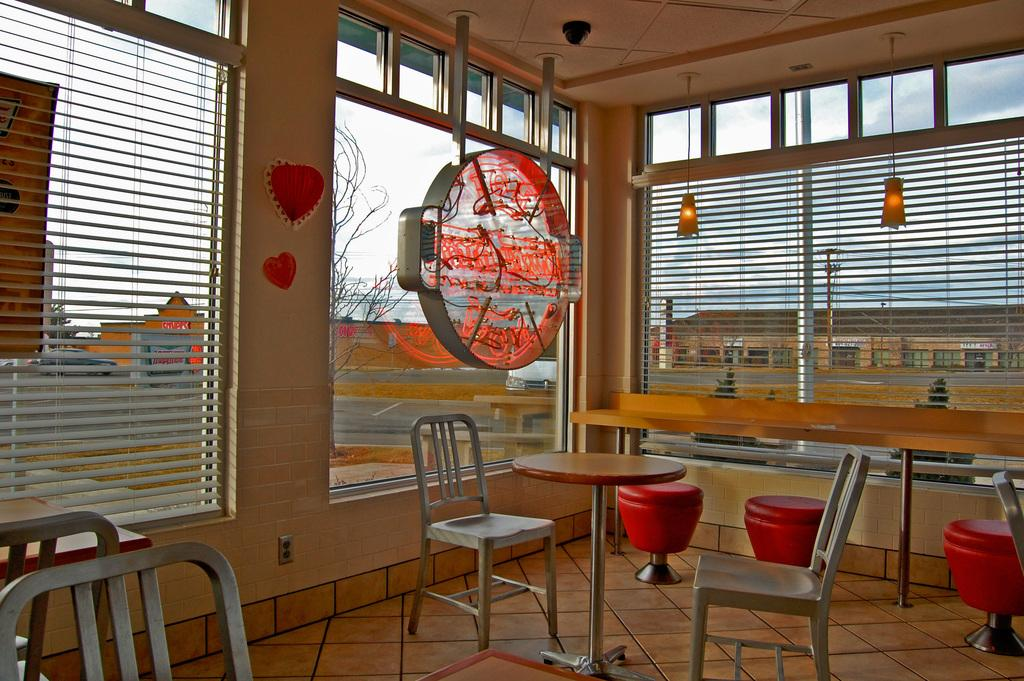What type of furniture is present in the image? There are chairs and tables in the image. What can be seen in the background of the image? There is a glass wall in the background of the image. What object is made of rope in the image? There is a rope in the image. How many women are present in the image? There is no mention of women in the provided facts, so we cannot determine the number of women in the image. 